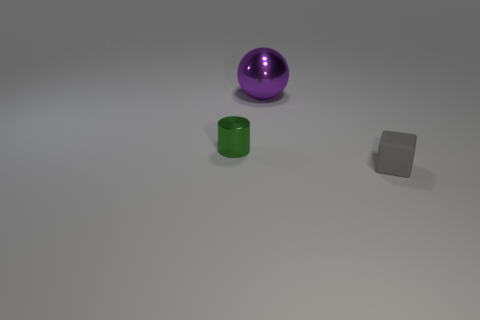Add 2 yellow metal things. How many objects exist? 5 Subtract 1 cylinders. How many cylinders are left? 0 Subtract 0 red cubes. How many objects are left? 3 Subtract all cylinders. How many objects are left? 2 Subtract all cyan blocks. Subtract all blue cylinders. How many blocks are left? 1 Subtract all tiny gray matte cubes. Subtract all purple metal objects. How many objects are left? 1 Add 2 tiny things. How many tiny things are left? 4 Add 3 purple spheres. How many purple spheres exist? 4 